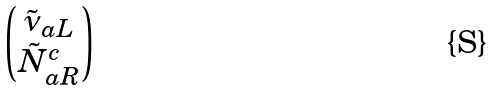Convert formula to latex. <formula><loc_0><loc_0><loc_500><loc_500>\begin{pmatrix} \tilde { \nu } _ { a L } \\ \tilde { N } _ { a R } ^ { c } \end{pmatrix}</formula> 